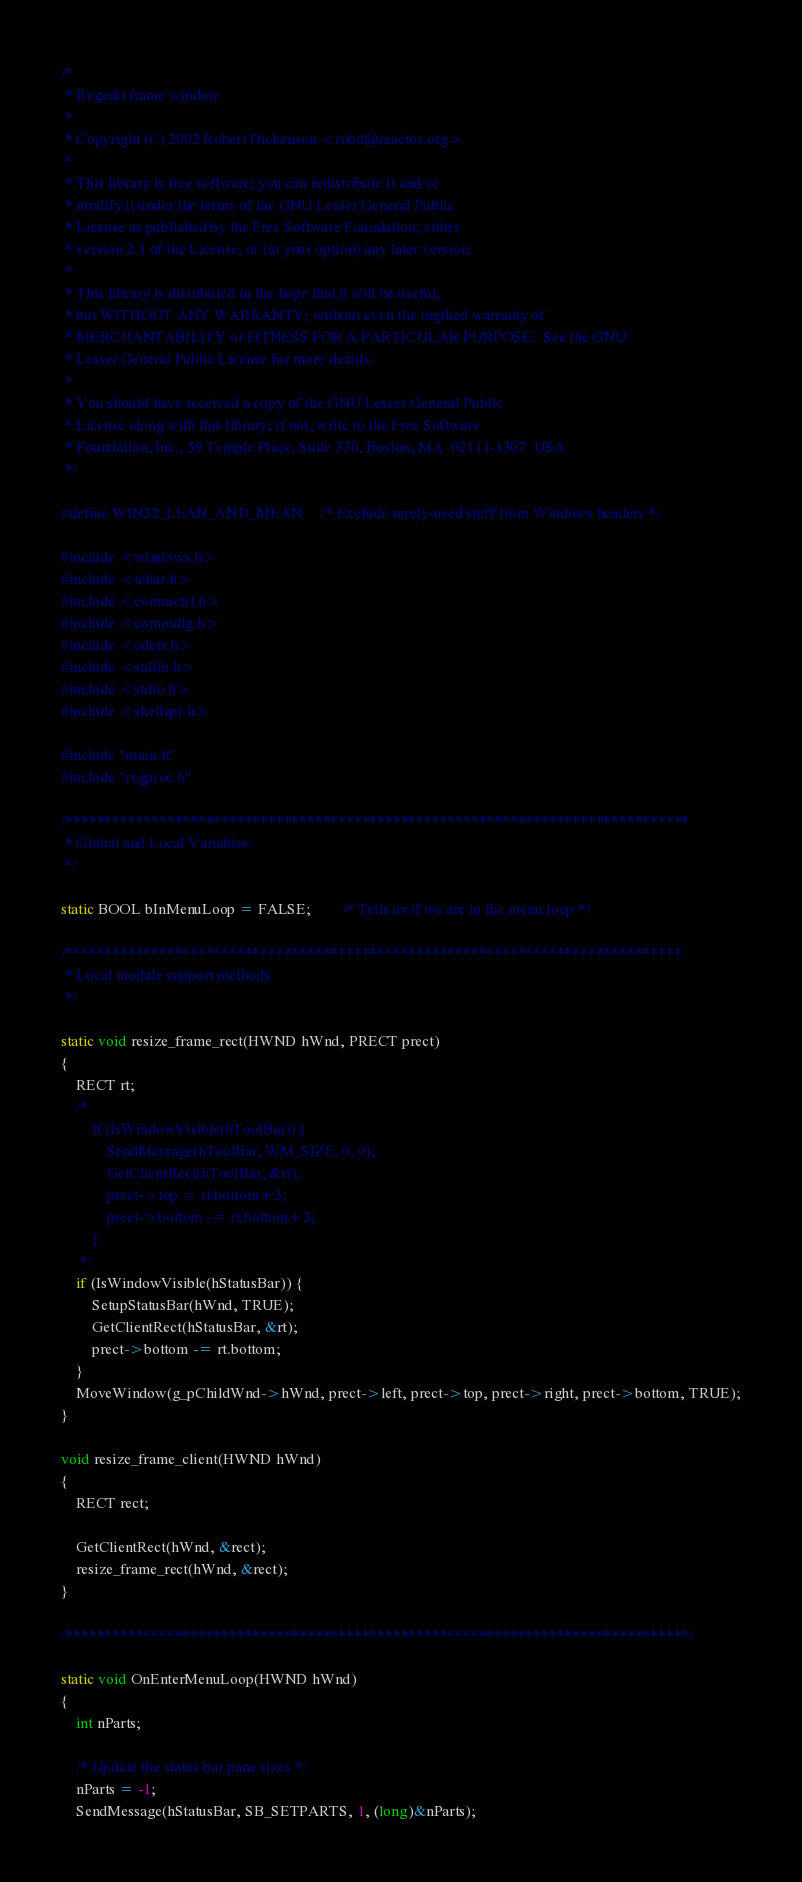<code> <loc_0><loc_0><loc_500><loc_500><_C_>/*
 * Regedit frame window
 *
 * Copyright (C) 2002 Robert Dickenson <robd@reactos.org>
 *
 * This library is free software; you can redistribute it and/or
 * modify it under the terms of the GNU Lesser General Public
 * License as published by the Free Software Foundation; either
 * version 2.1 of the License, or (at your option) any later version.
 *
 * This library is distributed in the hope that it will be useful,
 * but WITHOUT ANY WARRANTY; without even the implied warranty of
 * MERCHANTABILITY or FITNESS FOR A PARTICULAR PURPOSE.  See the GNU
 * Lesser General Public License for more details.
 *
 * You should have received a copy of the GNU Lesser General Public
 * License along with this library; if not, write to the Free Software
 * Foundation, Inc., 59 Temple Place, Suite 330, Boston, MA  02111-1307  USA
 */

#define WIN32_LEAN_AND_MEAN     /* Exclude rarely-used stuff from Windows headers */

#include <windows.h>
#include <tchar.h>
#include <commctrl.h>
#include <commdlg.h>
#include <cderr.h>
#include <stdlib.h>
#include <stdio.h>
#include <shellapi.h>

#include "main.h"
#include "regproc.h"

/********************************************************************************
 * Global and Local Variables:
 */

static BOOL bInMenuLoop = FALSE;        /* Tells us if we are in the menu loop */

/*******************************************************************************
 * Local module support methods
 */

static void resize_frame_rect(HWND hWnd, PRECT prect)
{
    RECT rt;
    /*
    	if (IsWindowVisible(hToolBar)) {
    		SendMessage(hToolBar, WM_SIZE, 0, 0);
    		GetClientRect(hToolBar, &rt);
    		prect->top = rt.bottom+3;
    		prect->bottom -= rt.bottom+3;
    	}
     */
    if (IsWindowVisible(hStatusBar)) {
        SetupStatusBar(hWnd, TRUE);
        GetClientRect(hStatusBar, &rt);
        prect->bottom -= rt.bottom;
    }
    MoveWindow(g_pChildWnd->hWnd, prect->left, prect->top, prect->right, prect->bottom, TRUE);
}

void resize_frame_client(HWND hWnd)
{
    RECT rect;

    GetClientRect(hWnd, &rect);
    resize_frame_rect(hWnd, &rect);
}

/********************************************************************************/

static void OnEnterMenuLoop(HWND hWnd)
{
    int nParts;

    /* Update the status bar pane sizes */
    nParts = -1;
    SendMessage(hStatusBar, SB_SETPARTS, 1, (long)&nParts);</code> 